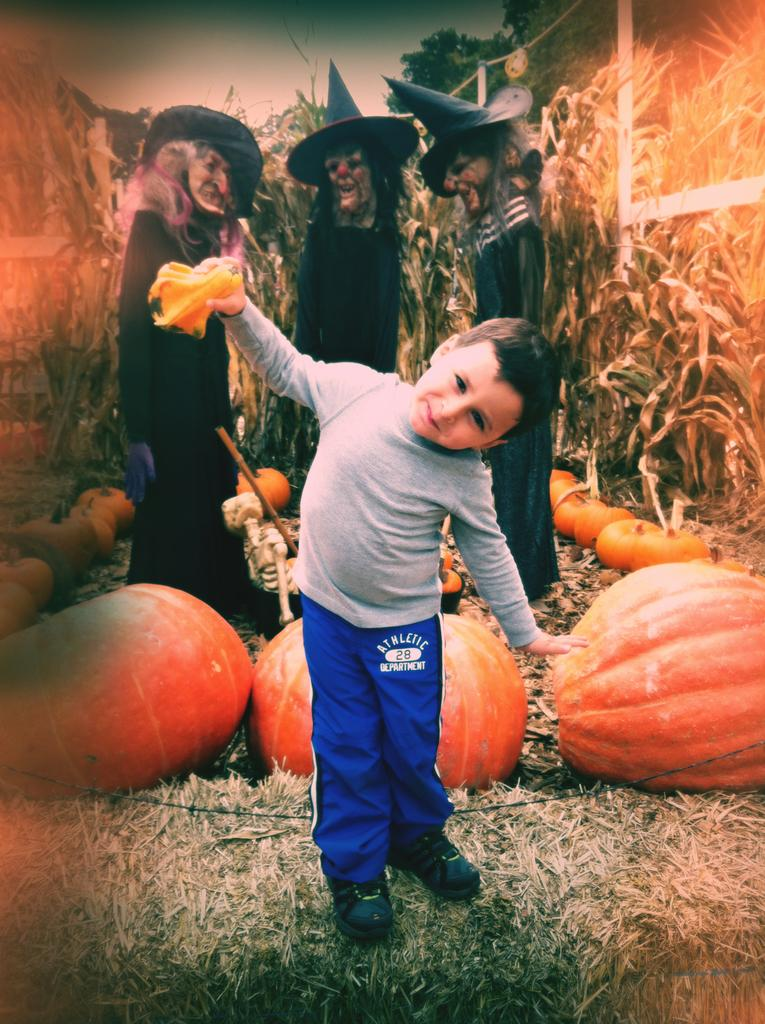What is the main subject of the image? There is a child in the image. What is the child wearing? The child is wearing a T-shirt. Where is the child standing? The child is standing on the ground. What can be seen in the background of the image? There are pumpkins, Halloween costumes, plants, and trees in the background of the image. What type of stem can be seen growing from the child's head in the image? There is no stem growing from the child's head in the image. How many horses are visible in the image? There are no horses present in the image. 